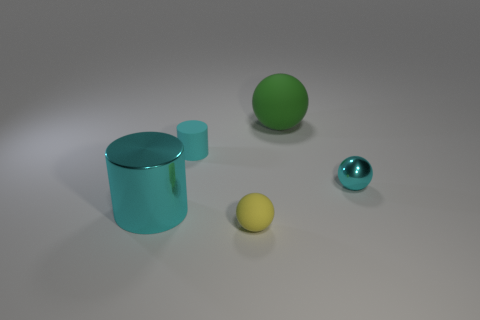Subtract all small spheres. How many spheres are left? 1 Add 2 green rubber spheres. How many objects exist? 7 Subtract 1 spheres. How many spheres are left? 2 Subtract all spheres. How many objects are left? 2 Subtract all blue balls. Subtract all green blocks. How many balls are left? 3 Add 4 tiny matte objects. How many tiny matte objects are left? 6 Add 3 big rubber things. How many big rubber things exist? 4 Subtract 0 gray blocks. How many objects are left? 5 Subtract all cyan rubber cylinders. Subtract all cyan matte cylinders. How many objects are left? 3 